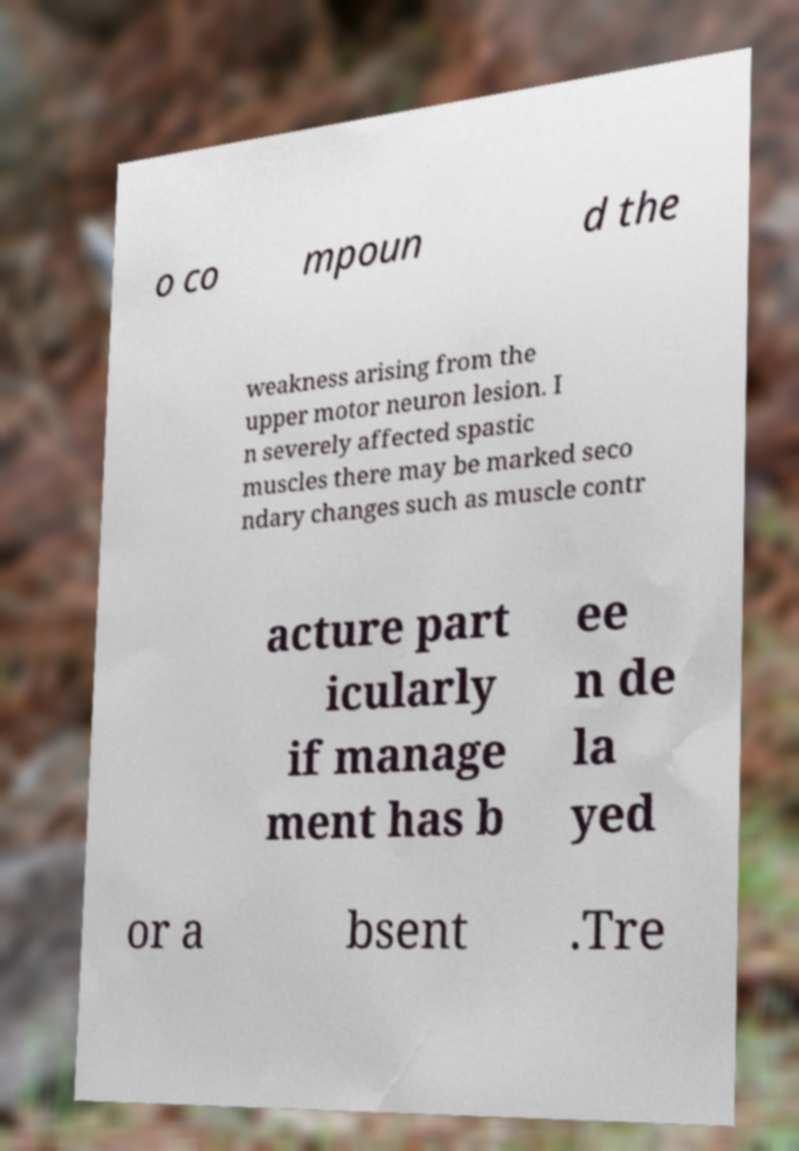Can you accurately transcribe the text from the provided image for me? o co mpoun d the weakness arising from the upper motor neuron lesion. I n severely affected spastic muscles there may be marked seco ndary changes such as muscle contr acture part icularly if manage ment has b ee n de la yed or a bsent .Tre 